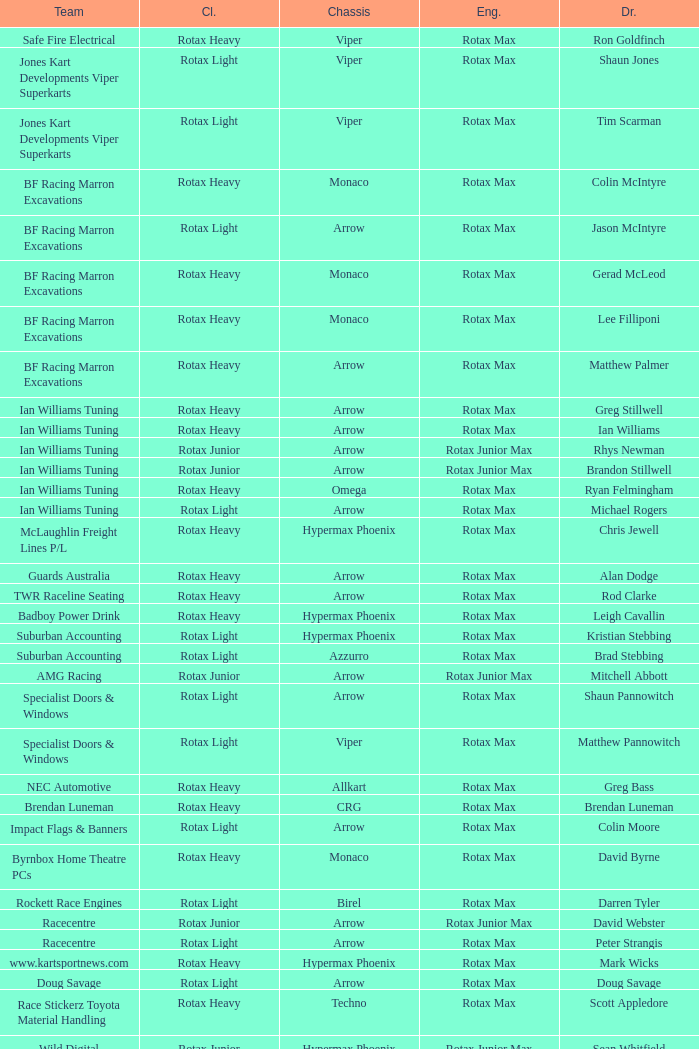What is the name of the team whose class is Rotax Light? Jones Kart Developments Viper Superkarts, Jones Kart Developments Viper Superkarts, BF Racing Marron Excavations, Ian Williams Tuning, Suburban Accounting, Suburban Accounting, Specialist Doors & Windows, Specialist Doors & Windows, Impact Flags & Banners, Rockett Race Engines, Racecentre, Doug Savage. 